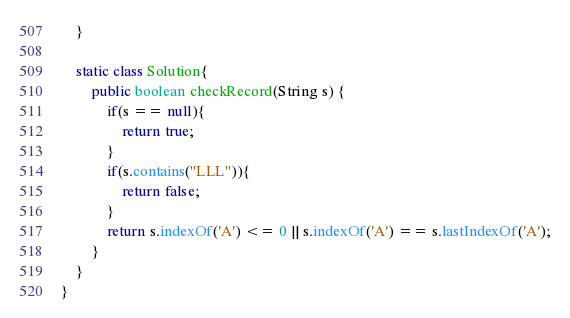<code> <loc_0><loc_0><loc_500><loc_500><_Java_>    }

    static class Solution{
        public boolean checkRecord(String s) {
            if(s == null){
                return true;
            }
            if(s.contains("LLL")){
                return false;
            }
            return s.indexOf('A') <= 0 || s.indexOf('A') == s.lastIndexOf('A');
        }
    }
}
</code> 